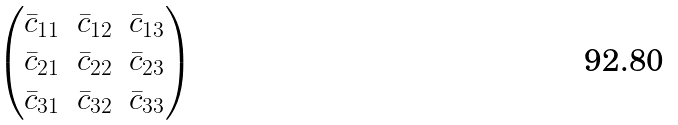<formula> <loc_0><loc_0><loc_500><loc_500>\begin{pmatrix} \bar { c } _ { 1 1 } & \bar { c } _ { 1 2 } & \bar { c } _ { 1 3 } \\ \bar { c } _ { 2 1 } & \bar { c } _ { 2 2 } & \bar { c } _ { 2 3 } \\ \bar { c } _ { 3 1 } & \bar { c } _ { 3 2 } & \bar { c } _ { 3 3 } \end{pmatrix}</formula> 